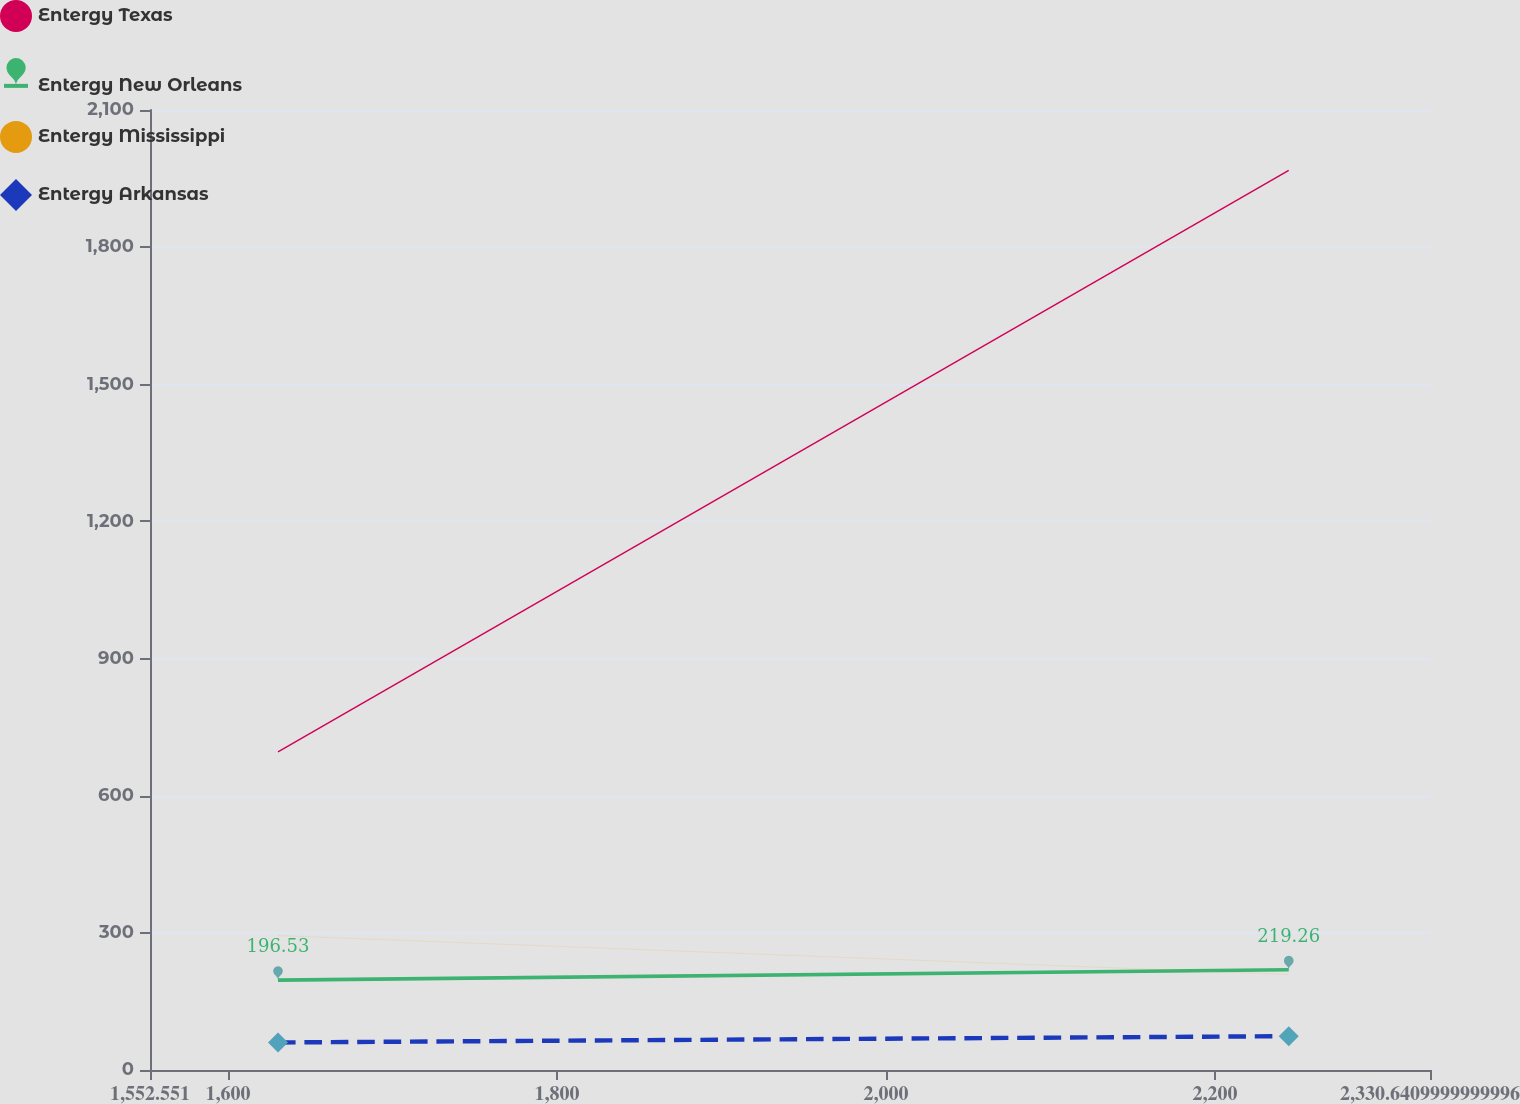Convert chart to OTSL. <chart><loc_0><loc_0><loc_500><loc_500><line_chart><ecel><fcel>Entergy Texas<fcel>Entergy New Orleans<fcel>Entergy Mississippi<fcel>Entergy Arkansas<nl><fcel>1630.36<fcel>696.06<fcel>196.53<fcel>294.06<fcel>60.25<nl><fcel>2244.77<fcel>1967.94<fcel>219.26<fcel>208.82<fcel>74.01<nl><fcel>2408.45<fcel>530.58<fcel>410.32<fcel>199.35<fcel>69.11<nl></chart> 